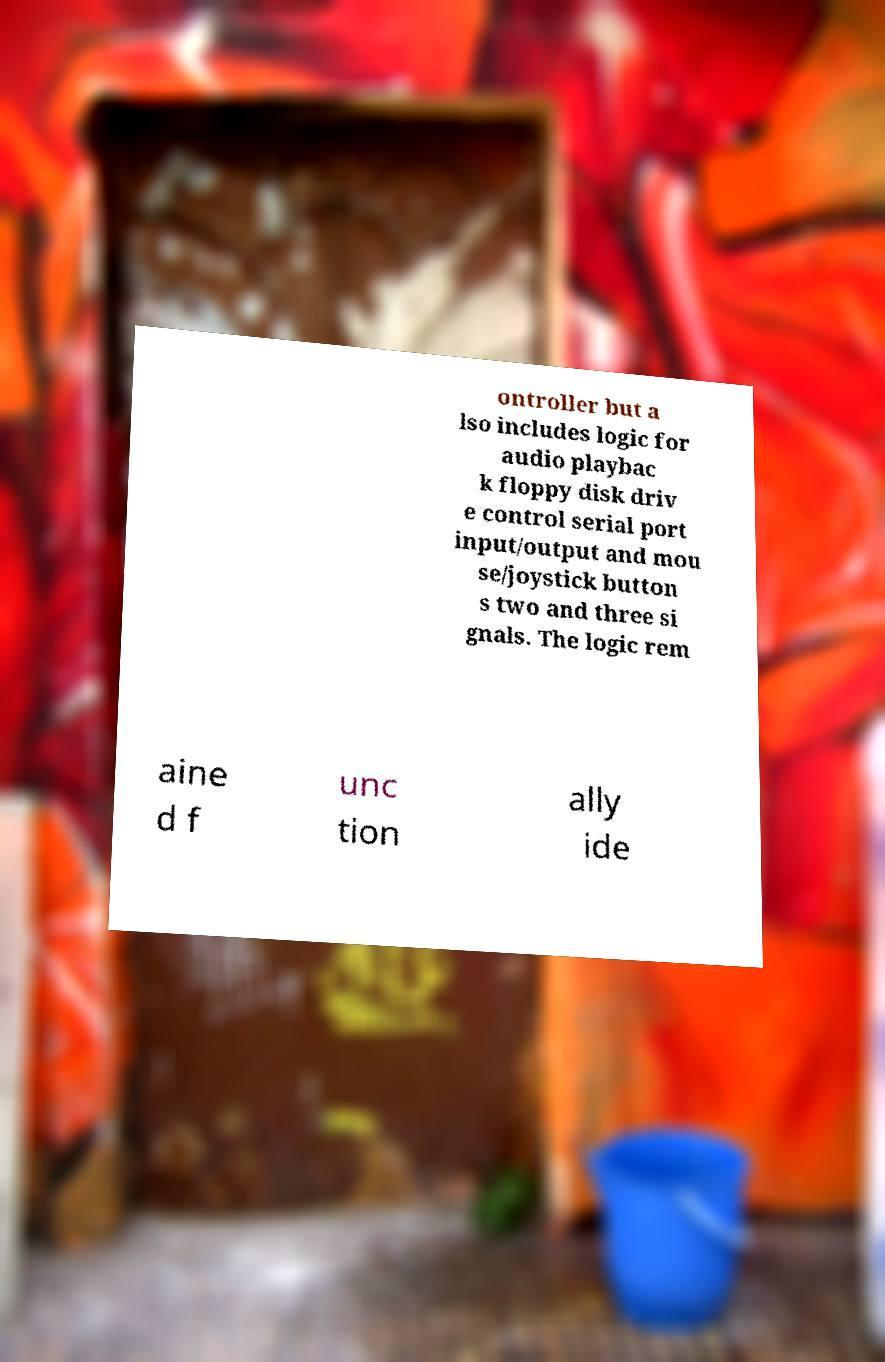Can you accurately transcribe the text from the provided image for me? ontroller but a lso includes logic for audio playbac k floppy disk driv e control serial port input/output and mou se/joystick button s two and three si gnals. The logic rem aine d f unc tion ally ide 